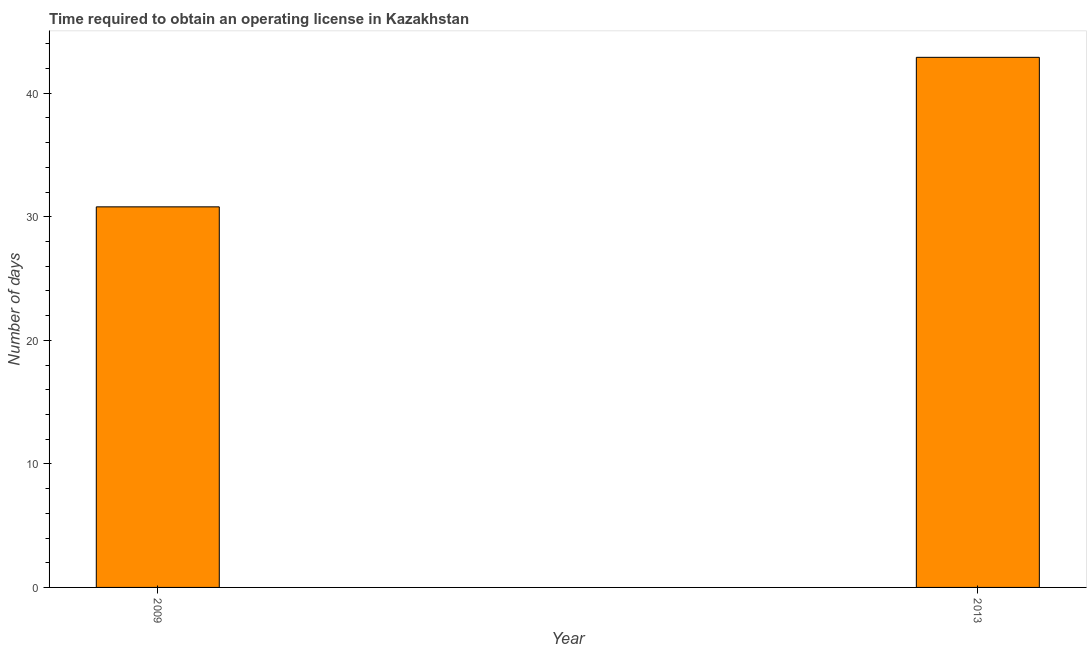Does the graph contain any zero values?
Provide a short and direct response. No. Does the graph contain grids?
Give a very brief answer. No. What is the title of the graph?
Offer a terse response. Time required to obtain an operating license in Kazakhstan. What is the label or title of the Y-axis?
Keep it short and to the point. Number of days. What is the number of days to obtain operating license in 2013?
Provide a short and direct response. 42.9. Across all years, what is the maximum number of days to obtain operating license?
Give a very brief answer. 42.9. Across all years, what is the minimum number of days to obtain operating license?
Your response must be concise. 30.8. In which year was the number of days to obtain operating license minimum?
Your answer should be very brief. 2009. What is the sum of the number of days to obtain operating license?
Your answer should be compact. 73.7. What is the difference between the number of days to obtain operating license in 2009 and 2013?
Keep it short and to the point. -12.1. What is the average number of days to obtain operating license per year?
Your answer should be compact. 36.85. What is the median number of days to obtain operating license?
Your response must be concise. 36.85. What is the ratio of the number of days to obtain operating license in 2009 to that in 2013?
Keep it short and to the point. 0.72. In how many years, is the number of days to obtain operating license greater than the average number of days to obtain operating license taken over all years?
Provide a short and direct response. 1. How many bars are there?
Offer a terse response. 2. Are the values on the major ticks of Y-axis written in scientific E-notation?
Make the answer very short. No. What is the Number of days in 2009?
Give a very brief answer. 30.8. What is the Number of days in 2013?
Provide a succinct answer. 42.9. What is the difference between the Number of days in 2009 and 2013?
Give a very brief answer. -12.1. What is the ratio of the Number of days in 2009 to that in 2013?
Your response must be concise. 0.72. 